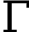<formula> <loc_0><loc_0><loc_500><loc_500>\Gamma</formula> 